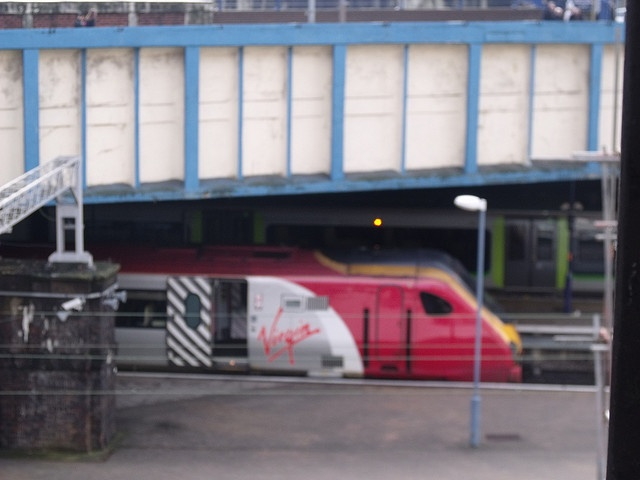Describe the objects in this image and their specific colors. I can see train in white, black, gray, and brown tones and train in white, black, gray, and darkgreen tones in this image. 